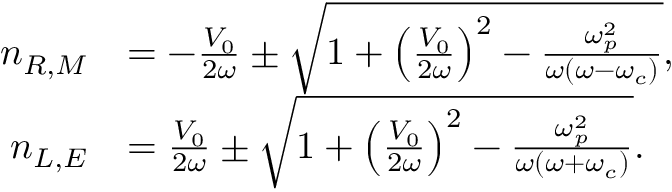<formula> <loc_0><loc_0><loc_500><loc_500>\begin{array} { r l } { n _ { R , M } } & { = - \frac { V _ { 0 } } { 2 \omega } \pm \sqrt { 1 + \left ( \frac { V _ { 0 } } { 2 \omega } \right ) ^ { 2 } - \frac { \omega _ { p } ^ { 2 } } { \omega ( \omega - \omega _ { c } ) } } , } \\ { n _ { L , E } } & { = \frac { V _ { 0 } } { 2 \omega } \pm \sqrt { 1 + \left ( \frac { V _ { 0 } } { 2 \omega } \right ) ^ { 2 } - \frac { \omega _ { p } ^ { 2 } } { \omega ( \omega + \omega _ { c } ) } } . } \end{array}</formula> 